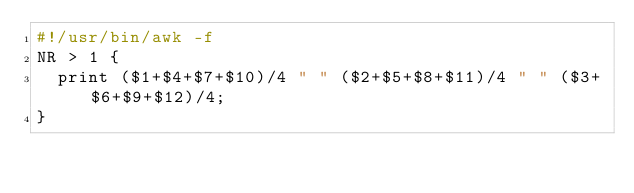Convert code to text. <code><loc_0><loc_0><loc_500><loc_500><_Awk_>#!/usr/bin/awk -f
NR > 1 {
  print ($1+$4+$7+$10)/4 " " ($2+$5+$8+$11)/4 " " ($3+$6+$9+$12)/4;   
}
</code> 